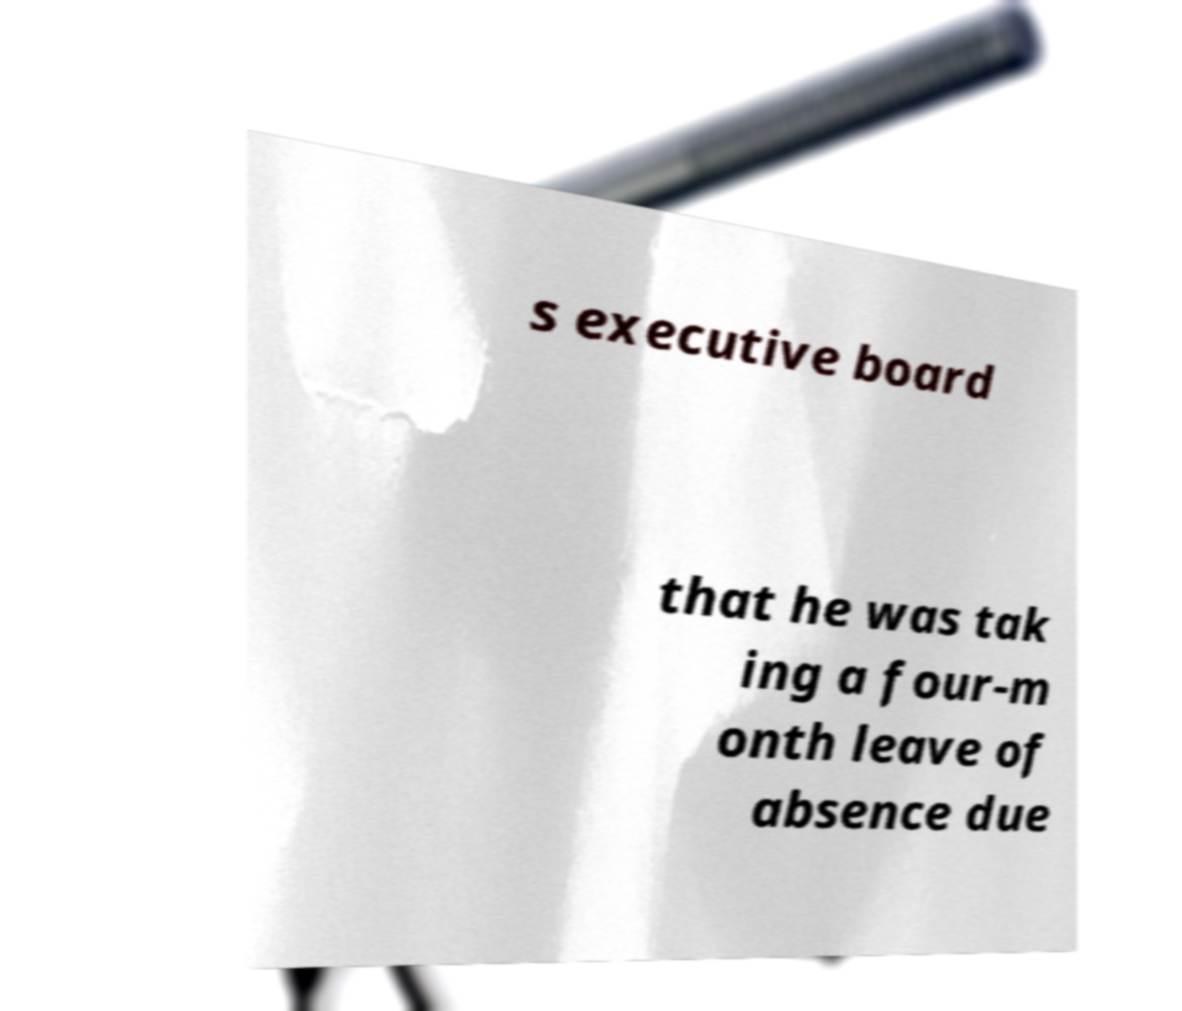What messages or text are displayed in this image? I need them in a readable, typed format. s executive board that he was tak ing a four-m onth leave of absence due 